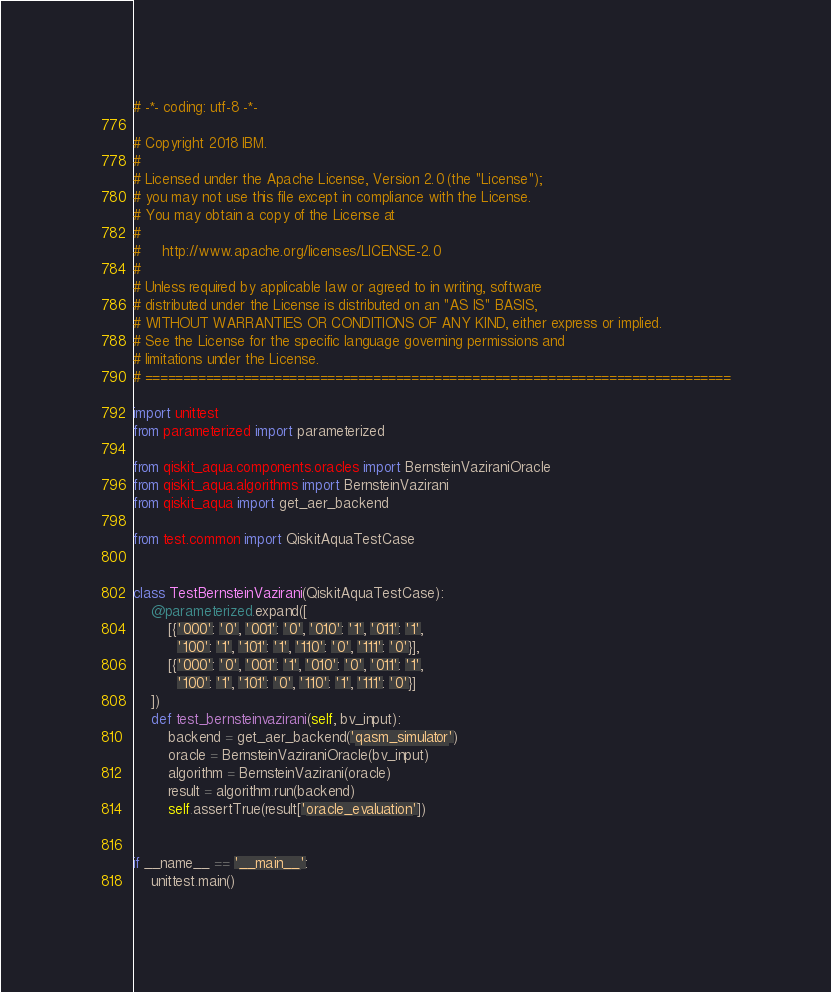<code> <loc_0><loc_0><loc_500><loc_500><_Python_># -*- coding: utf-8 -*-

# Copyright 2018 IBM.
#
# Licensed under the Apache License, Version 2.0 (the "License");
# you may not use this file except in compliance with the License.
# You may obtain a copy of the License at
#
#     http://www.apache.org/licenses/LICENSE-2.0
#
# Unless required by applicable law or agreed to in writing, software
# distributed under the License is distributed on an "AS IS" BASIS,
# WITHOUT WARRANTIES OR CONDITIONS OF ANY KIND, either express or implied.
# See the License for the specific language governing permissions and
# limitations under the License.
# =============================================================================

import unittest
from parameterized import parameterized

from qiskit_aqua.components.oracles import BernsteinVaziraniOracle
from qiskit_aqua.algorithms import BernsteinVazirani
from qiskit_aqua import get_aer_backend

from test.common import QiskitAquaTestCase


class TestBernsteinVazirani(QiskitAquaTestCase):
    @parameterized.expand([
        [{'000': '0', '001': '0', '010': '1', '011': '1',
          '100': '1', '101': '1', '110': '0', '111': '0'}],
        [{'000': '0', '001': '1', '010': '0', '011': '1',
          '100': '1', '101': '0', '110': '1', '111': '0'}]
    ])
    def test_bernsteinvazirani(self, bv_input):
        backend = get_aer_backend('qasm_simulator')
        oracle = BernsteinVaziraniOracle(bv_input)
        algorithm = BernsteinVazirani(oracle)
        result = algorithm.run(backend)
        self.assertTrue(result['oracle_evaluation'])


if __name__ == '__main__':
    unittest.main()
</code> 